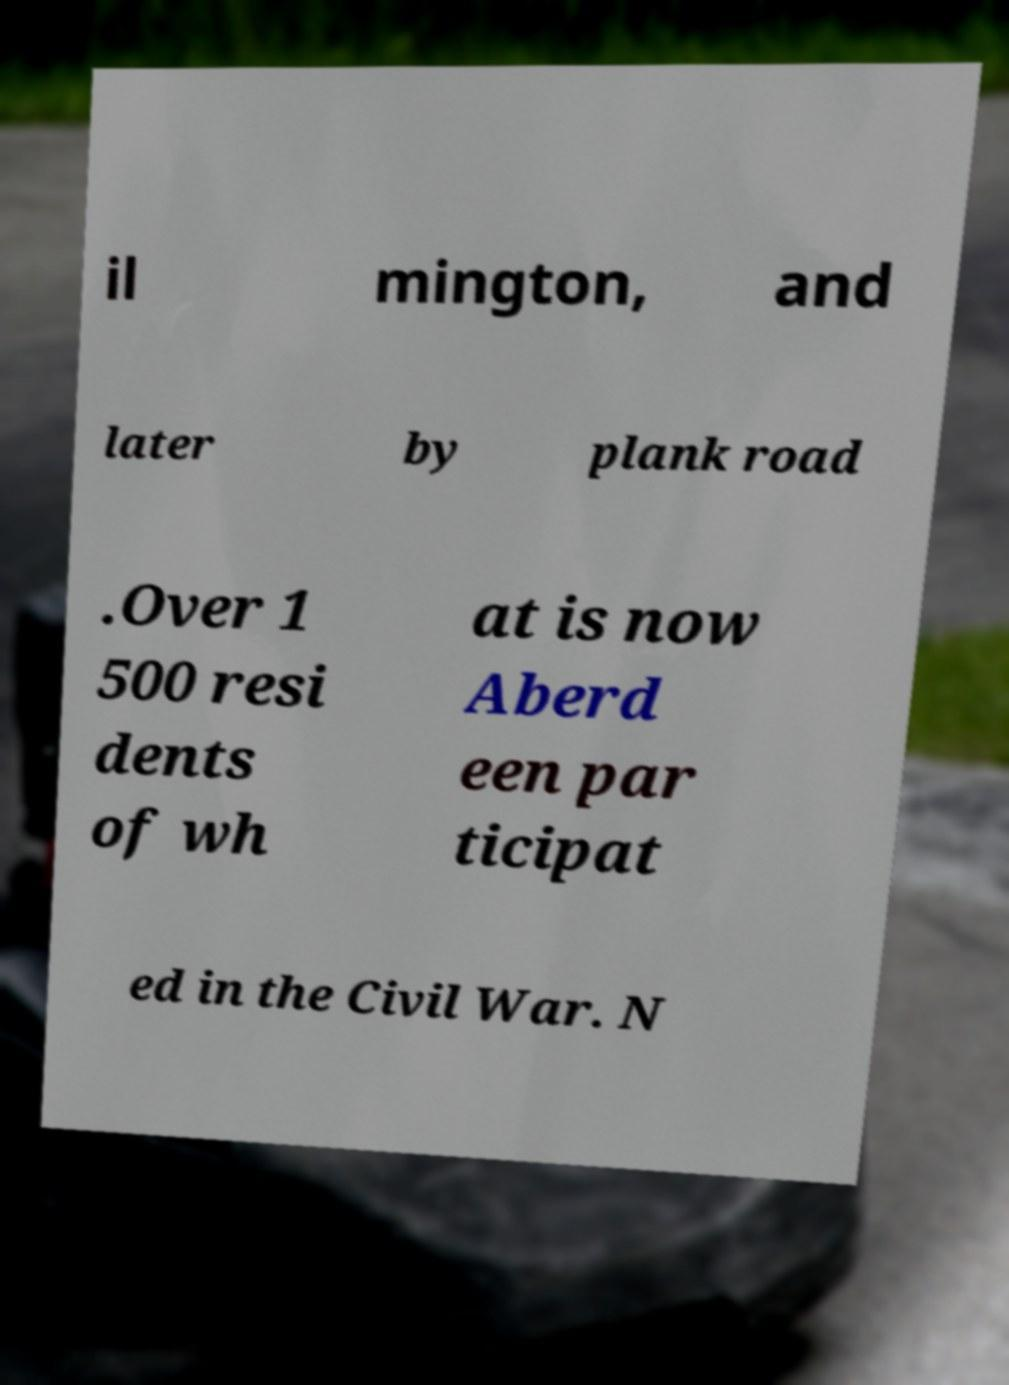For documentation purposes, I need the text within this image transcribed. Could you provide that? il mington, and later by plank road .Over 1 500 resi dents of wh at is now Aberd een par ticipat ed in the Civil War. N 